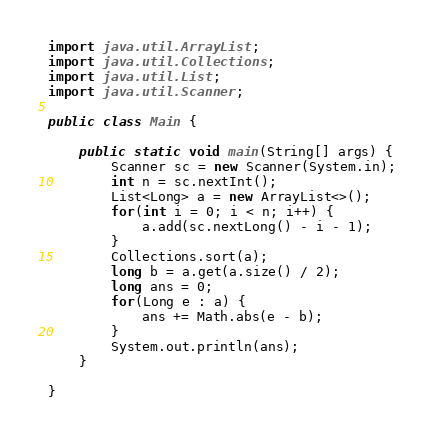<code> <loc_0><loc_0><loc_500><loc_500><_Java_>
import java.util.ArrayList;
import java.util.Collections;
import java.util.List;
import java.util.Scanner;

public class Main {

	public static void main(String[] args) {
		Scanner sc = new Scanner(System.in);
		int n = sc.nextInt();
		List<Long> a = new ArrayList<>();
		for(int i = 0; i < n; i++) {
			a.add(sc.nextLong() - i - 1);
		}
		Collections.sort(a);
		long b = a.get(a.size() / 2);
		long ans = 0;
		for(Long e : a) {
			ans += Math.abs(e - b);
		}
		System.out.println(ans);
	}

}
</code> 